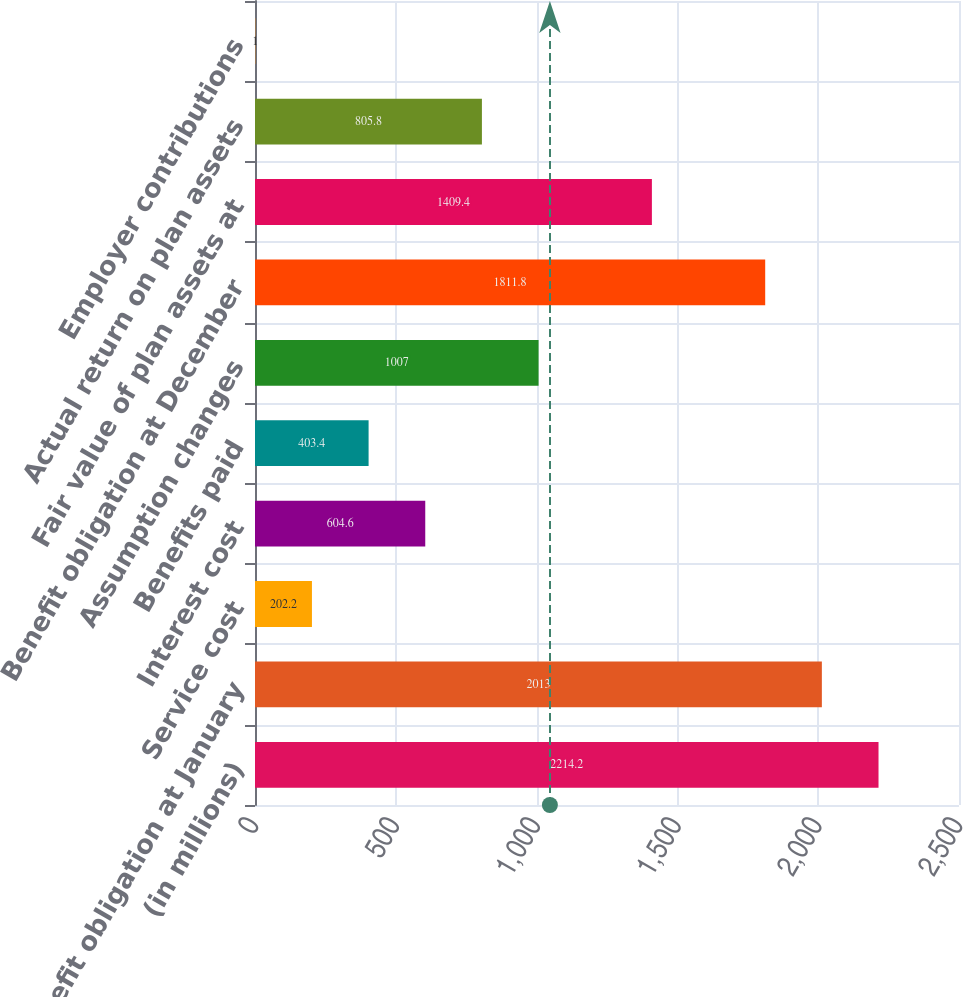<chart> <loc_0><loc_0><loc_500><loc_500><bar_chart><fcel>(in millions)<fcel>Benefit obligation at January<fcel>Service cost<fcel>Interest cost<fcel>Benefits paid<fcel>Assumption changes<fcel>Benefit obligation at December<fcel>Fair value of plan assets at<fcel>Actual return on plan assets<fcel>Employer contributions<nl><fcel>2214.2<fcel>2013<fcel>202.2<fcel>604.6<fcel>403.4<fcel>1007<fcel>1811.8<fcel>1409.4<fcel>805.8<fcel>1<nl></chart> 